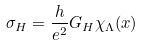Convert formula to latex. <formula><loc_0><loc_0><loc_500><loc_500>\sigma _ { H } = \frac { h } { e ^ { 2 } } G _ { H } \chi _ { \Lambda } ( x )</formula> 